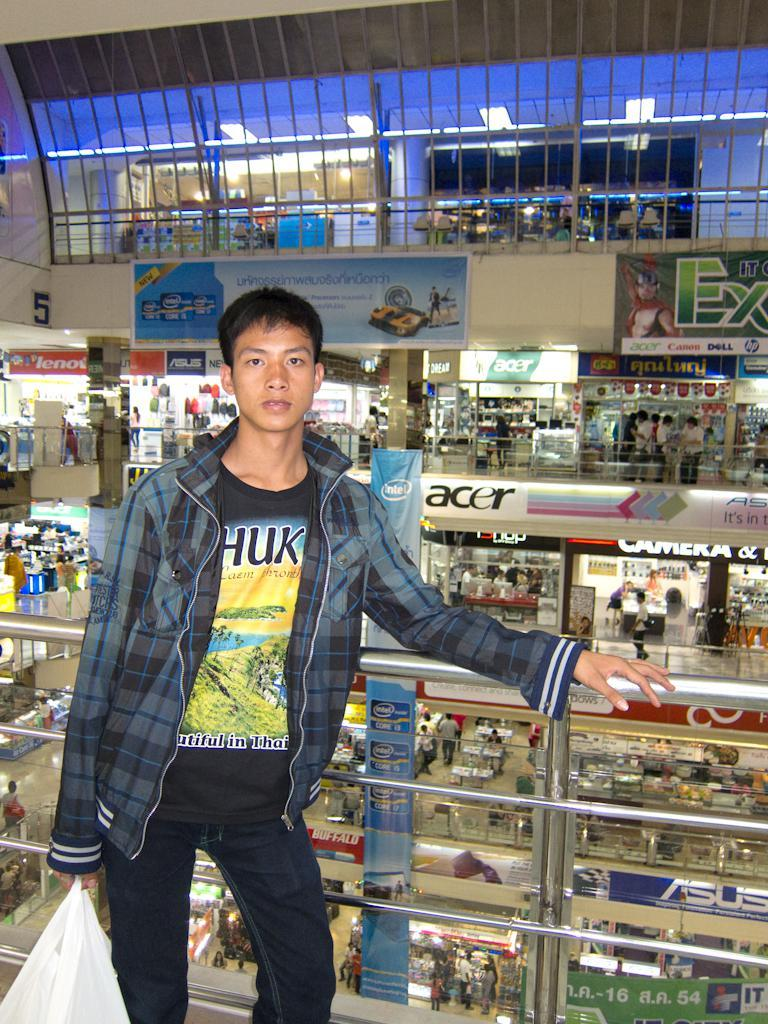What is the main subject of the image? There is a person standing in the center of the image. What is the person holding in his hand? The person is holding a cover in his hand. What can be seen in the background of the image? There are many stores in the background of the image. Can you see any boats or ships in the harbor in the image? There is no harbor or boats visible in the image; it features a person holding a cover and stores in the background. What type of skin condition is the person suffering from in the image? There is no indication of any skin condition in the image; the person is simply holding a cover. 